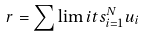<formula> <loc_0><loc_0><loc_500><loc_500>r = \sum \lim i t s _ { i = 1 } ^ { N } u _ { i }</formula> 